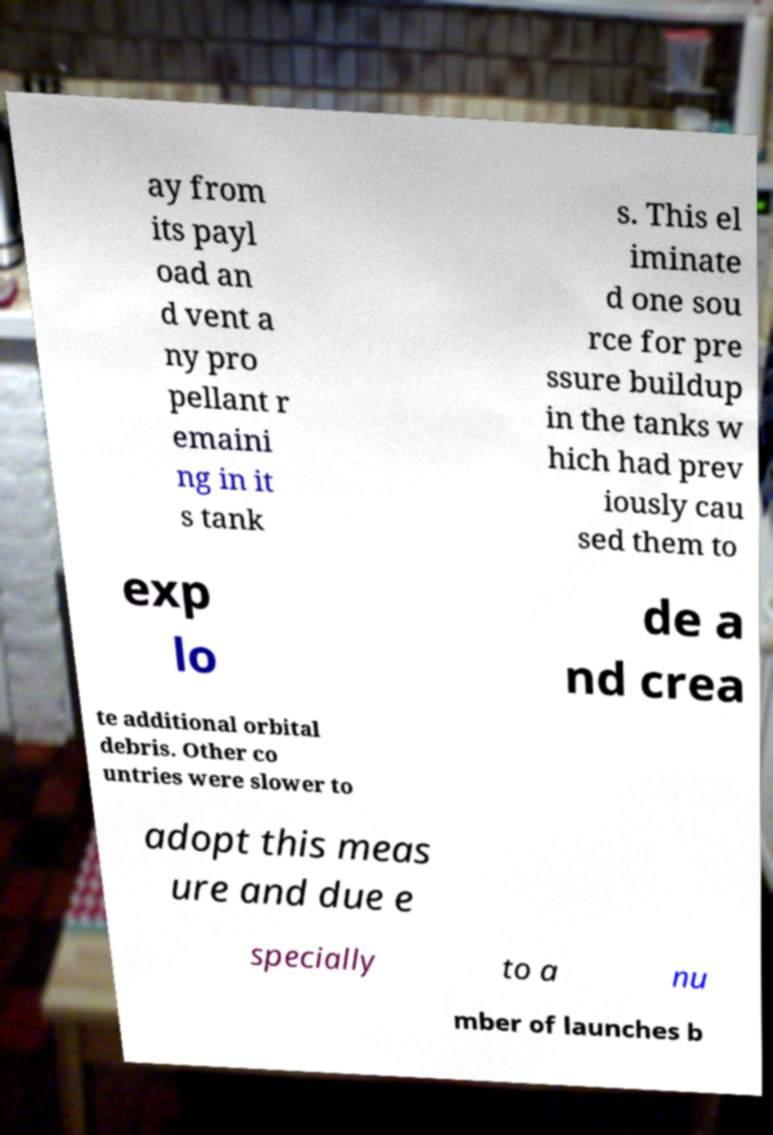Please identify and transcribe the text found in this image. ay from its payl oad an d vent a ny pro pellant r emaini ng in it s tank s. This el iminate d one sou rce for pre ssure buildup in the tanks w hich had prev iously cau sed them to exp lo de a nd crea te additional orbital debris. Other co untries were slower to adopt this meas ure and due e specially to a nu mber of launches b 